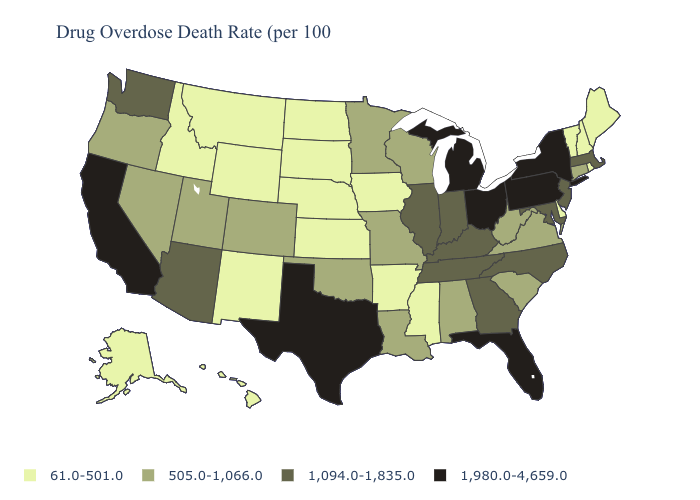Does Ohio have the lowest value in the USA?
Short answer required. No. Does Indiana have the lowest value in the USA?
Write a very short answer. No. How many symbols are there in the legend?
Concise answer only. 4. What is the value of New Mexico?
Give a very brief answer. 61.0-501.0. What is the value of Georgia?
Answer briefly. 1,094.0-1,835.0. Does Alaska have the highest value in the USA?
Keep it brief. No. Is the legend a continuous bar?
Keep it brief. No. Among the states that border Alabama , does Tennessee have the highest value?
Be succinct. No. Does Michigan have the highest value in the MidWest?
Be succinct. Yes. What is the value of Maine?
Give a very brief answer. 61.0-501.0. Name the states that have a value in the range 1,094.0-1,835.0?
Give a very brief answer. Arizona, Georgia, Illinois, Indiana, Kentucky, Maryland, Massachusetts, New Jersey, North Carolina, Tennessee, Washington. What is the lowest value in the USA?
Concise answer only. 61.0-501.0. What is the highest value in states that border Alabama?
Answer briefly. 1,980.0-4,659.0. What is the lowest value in the Northeast?
Keep it brief. 61.0-501.0. Which states have the highest value in the USA?
Be succinct. California, Florida, Michigan, New York, Ohio, Pennsylvania, Texas. 